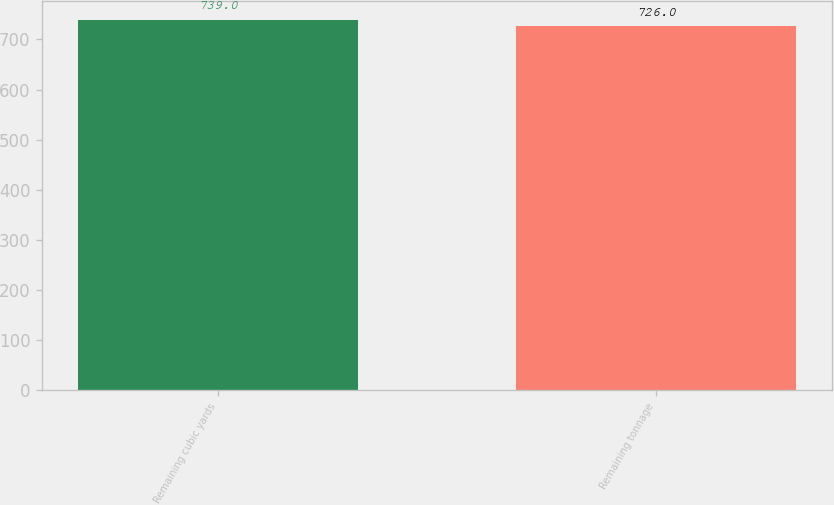Convert chart to OTSL. <chart><loc_0><loc_0><loc_500><loc_500><bar_chart><fcel>Remaining cubic yards<fcel>Remaining tonnage<nl><fcel>739<fcel>726<nl></chart> 